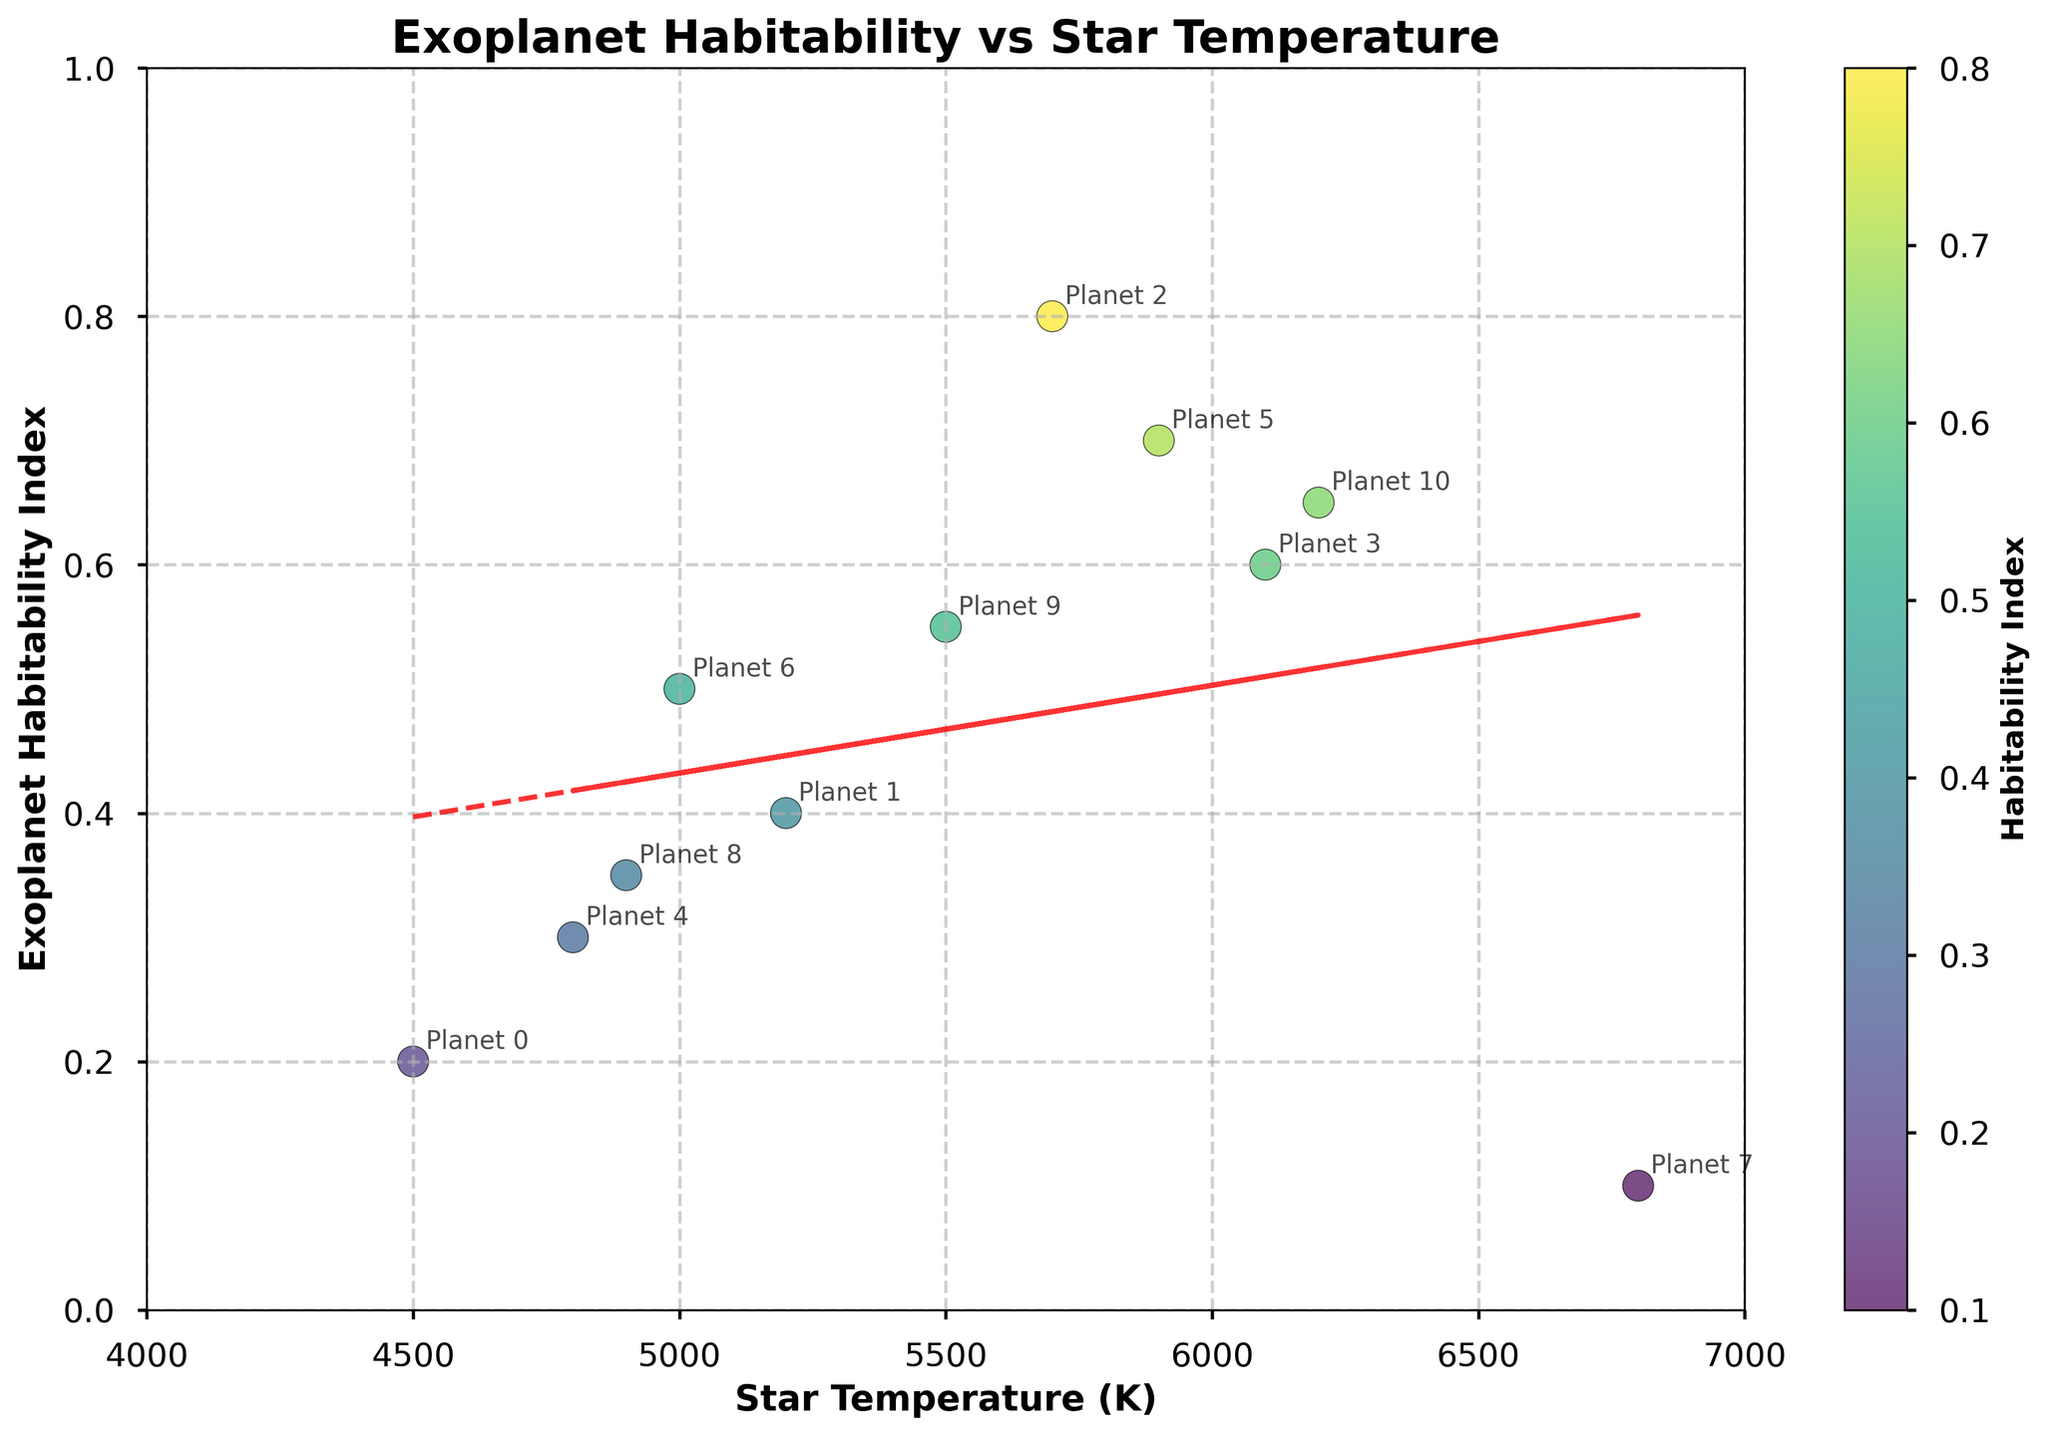What is the title of the plot? The title of the plot is displayed at the top and reads "Exoplanet Habitability vs Star Temperature."
Answer: Exoplanet Habitability vs Star Temperature What is the range of the x-axis? The x-axis represents the star temperature and ranges from 4000 K to 7000 K, as indicated by the axis limits.
Answer: 4000 K - 7000 K How many data points are plotted on the scatter plot? You can count the number of distinct points on the scatter plot; it is the total number of exoplanets. Since the data table includes 11 rows, there are 11 data points.
Answer: 11 Which star temperature corresponds to the highest exoplanet habitability index? By checking the y-values, the highest habitability index is 0.8, which corresponds to a star temperature of 5700 K.
Answer: 5700 K What is the exoplanet habitability index at a star temperature of 6800 K? Locating the point at a star temperature of 6800 K, the corresponding habitability index is 0.1.
Answer: 0.1 Which exoplanet has the lowest habitability index, and what is its star temperature? The lowest habitability index can be identified visually; it is 0.1, corresponding to a star temperature of 6800 K.
Answer: 6800 K, 0.1 Is there a general trend between star temperature and exoplanet habitability index? What is it? Observing the trend line (red dashed line), there is a general positive trend: as the star temperature increases, the habitability index tends to increase slightly.
Answer: Positive correlation What is the range of the habitability index values? The y-axis represents the habitability index and ranges from 0 to 1, as indicated by the axis limits.
Answer: 0 - 1 Identify the planets that have a star temperature of exactly 5000 K. What are their habitability indices? Checking for points at a star temperature of 5000 K, there is one planet with a habitability index of 0.5.
Answer: 0.5 Which exoplanet has the highest habitability index, and what is its star temperature? The highest habitability index is 0.8, which corresponds to a star temperature of 5700 K.
Answer: 5700 K, 0.8 